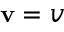Convert formula to latex. <formula><loc_0><loc_0><loc_500><loc_500>v = v</formula> 